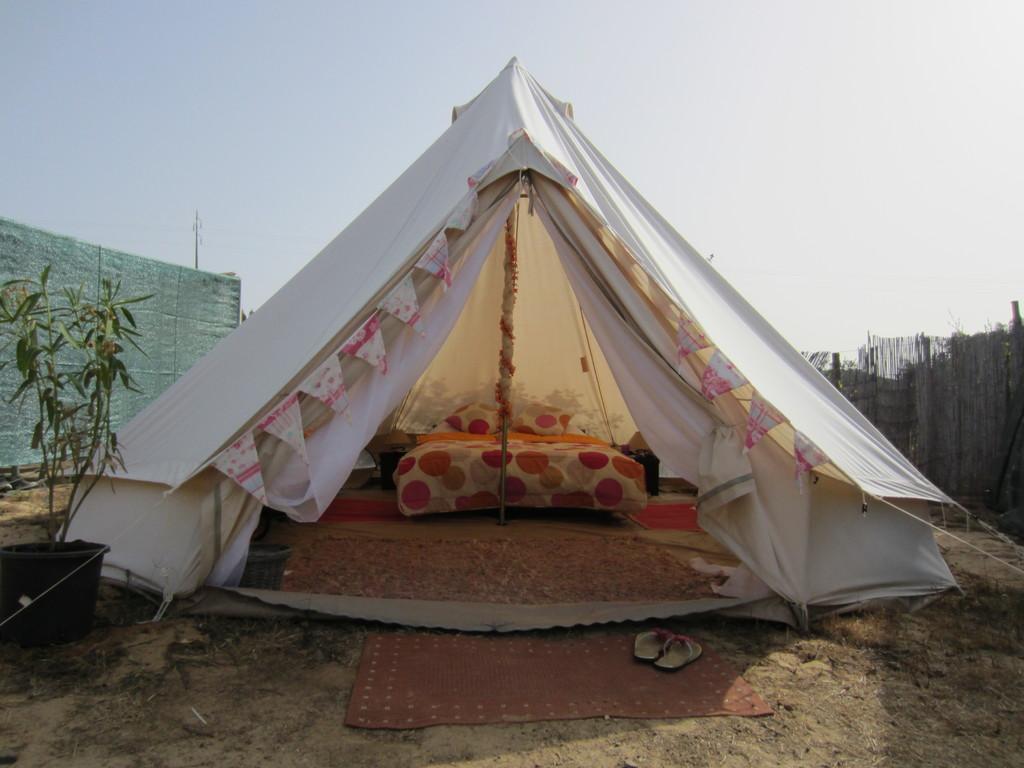Please provide a concise description of this image. In this image we can see a tent. Inside the tent, we can see pole, bed, pillows and carpet. At the bottom of the image, we can see slippers and door mat on the land. There is a potted plant on the left side of the image. It seems like one more tent in the background. There is a fence on the right side of the image. At the top of the image, we can see the sky. 